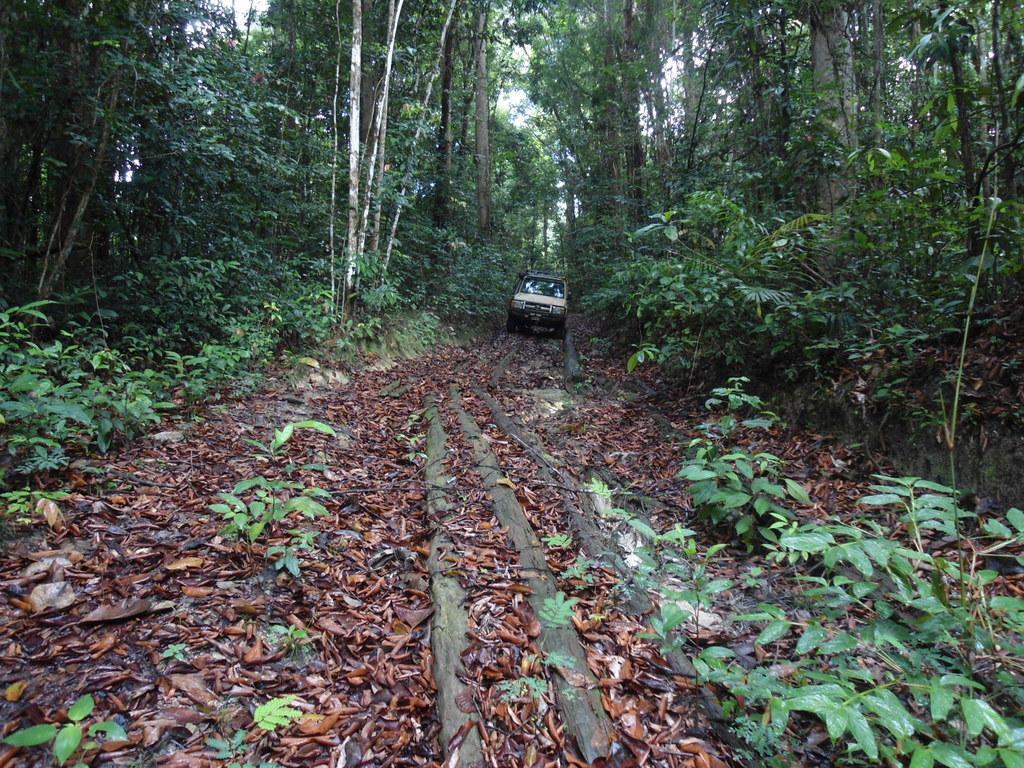Describe this image in one or two sentences. In this picture we can see car which is standing on this wood. On the background we can see many trees. On the bottom right corner we can see plants. Here it's a sky. On the bottom we can see leaves. 